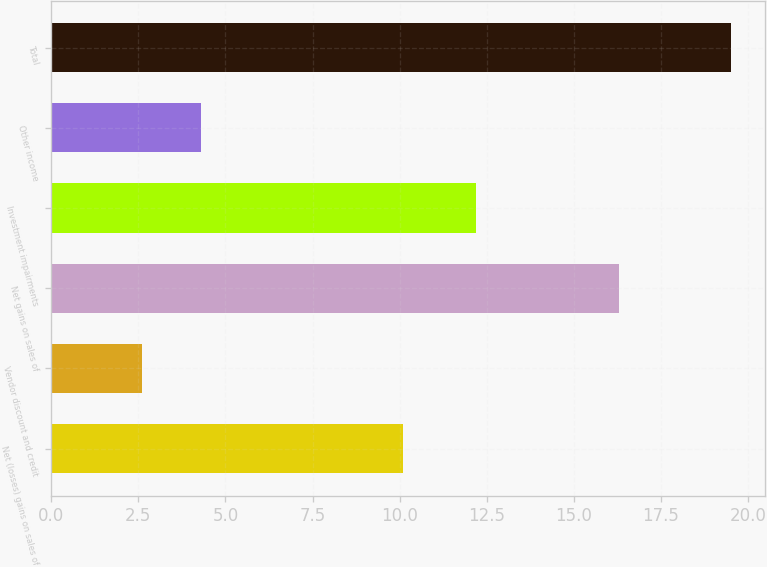Convert chart to OTSL. <chart><loc_0><loc_0><loc_500><loc_500><bar_chart><fcel>Net (losses) gains on sales of<fcel>Vendor discount and credit<fcel>Net gains on sales of<fcel>Investment impairments<fcel>Other income<fcel>Total<nl><fcel>10.1<fcel>2.6<fcel>16.3<fcel>12.2<fcel>4.29<fcel>19.5<nl></chart> 